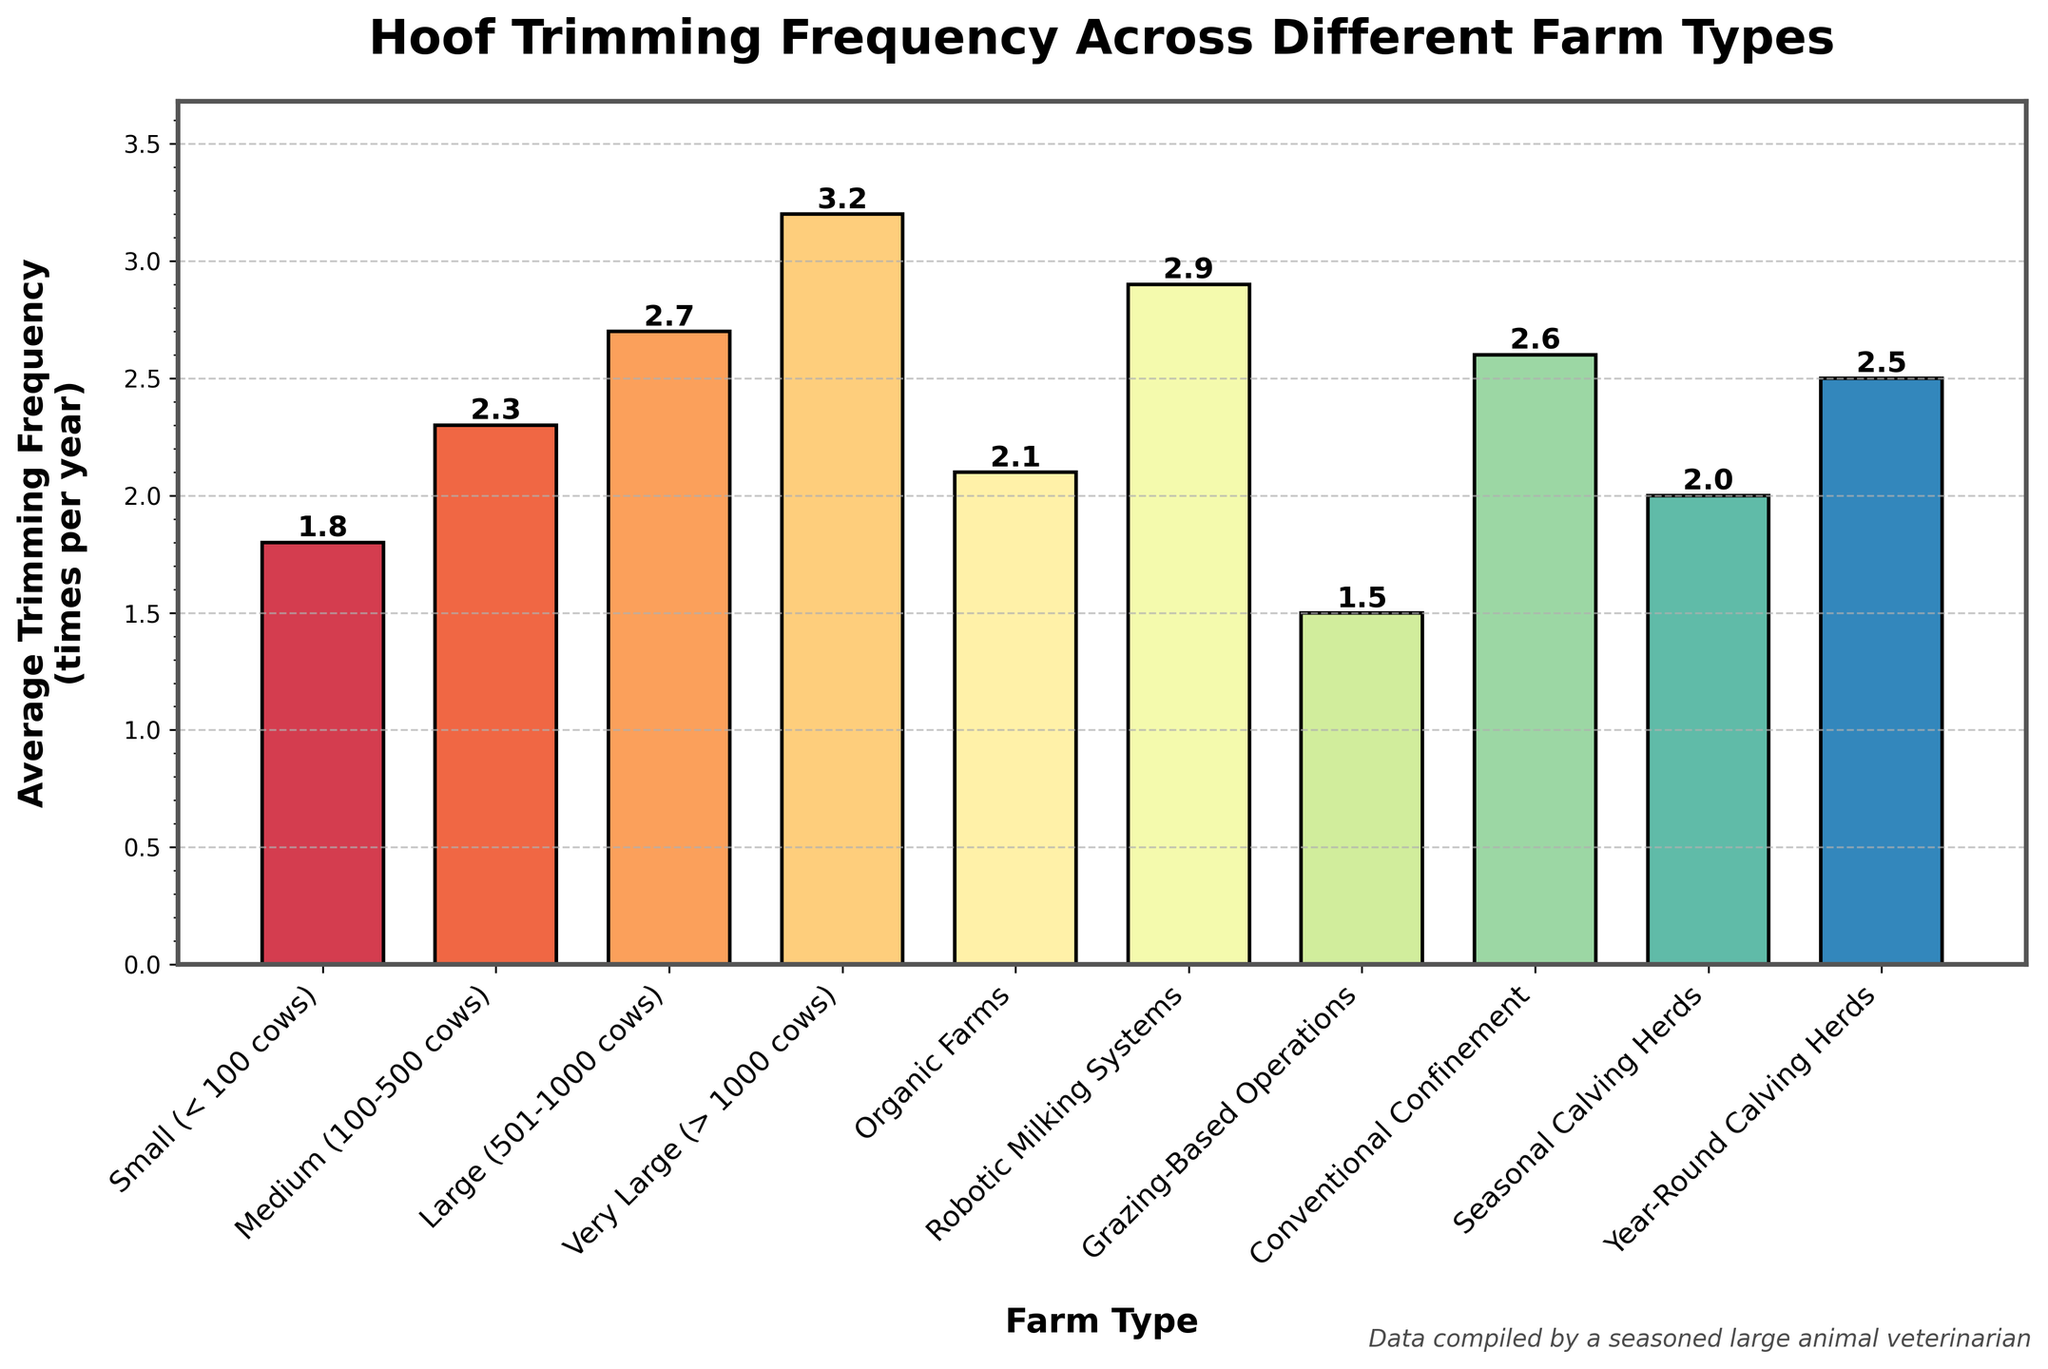What is the average hoof trimming frequency for Organic Farms? The figure shows that Organic Farms have an average hoof trimming frequency of 2.1 times per year, as indicated by the height of the corresponding bar and the value label at the top.
Answer: 2.1 Which farm type has the highest average hoof trimming frequency? The bar corresponding to Very Large (> 1000 cows) farms is the tallest, indicating it has the highest average hoof trimming frequency at 3.2 times per year.
Answer: Very Large (> 1000 cows) How does the average trimming frequency of Year-Round Calving Herds compare to that of Seasonal Calving Herds? Year-Round Calving Herds have a trimming frequency of 2.5 times per year, while Seasonal Calving Herds have a frequency of 2.0 times per year. Year-Round Calving Herds have a higher trimming frequency than Seasonal Calving Herds by 0.5 times per year.
Answer: 0.5 times higher What is the difference in hoof trimming frequency between Small (< 100 cows) farms and Large (501-1000 cows) farms? Small farms have an average frequency of 1.8 times per year, and Large farms have an average frequency of 2.7 times per year. The difference is 2.7 - 1.8 = 0.9 times per year.
Answer: 0.9 times What is the combined average hoof trimming frequency for Medium (100-500 cows) and Organic Farms? Medium farms have a frequency of 2.3 times per year, and Organic Farms have a frequency of 2.1 times per year. Their combined average is (2.3 + 2.1) / 2 = 2.2 times per year.
Answer: 2.2 Which farm type has a lower hoof trimming frequency: Grazing-Based Operations or Conventional Confinement? Grazing-Based Operations have a trimming frequency of 1.5 times per year, while Conventional Confinement has a frequency of 2.6 times per year. Grazing-Based Operations have a lower frequency.
Answer: Grazing-Based Operations What is the median hoof trimming frequency among all farm types? To find the median, list the frequencies in ascending order: 1.5, 1.8, 2.0, 2.1, 2.3, 2.5, 2.6, 2.7, 2.9, 3.2. The median is the average of the 5th and 6th values: (2.3 + 2.5) / 2 = 2.4.
Answer: 2.4 How much more frequently are hooves trimmed on farms with Robotic Milking Systems compared to Small (< 100 cows) farms? Robotic Milking Systems have a frequency of 2.9 times per year, and Small farms have a frequency of 1.8 times per year. The difference is 2.9 - 1.8 = 1.1 times per year.
Answer: 1.1 times Which three farm types have the lowest average hoof trimming frequencies? The three shortest bars correspond to Grazing-Based Operations (1.5 times per year), Small (< 100 cows) farms (1.8 times per year), and Seasonal Calving Herds (2.0 times per year).
Answer: Grazing-Based Operations, Small farms, Seasonal Calving Herds 